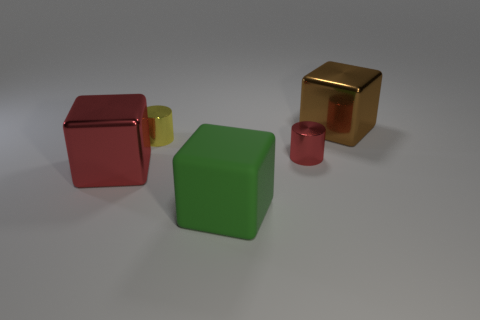Add 2 tiny things. How many objects exist? 7 Subtract all cubes. How many objects are left? 2 Subtract all green matte blocks. Subtract all small red metal cylinders. How many objects are left? 3 Add 3 large shiny objects. How many large shiny objects are left? 5 Add 5 big green matte cubes. How many big green matte cubes exist? 6 Subtract 0 purple cubes. How many objects are left? 5 